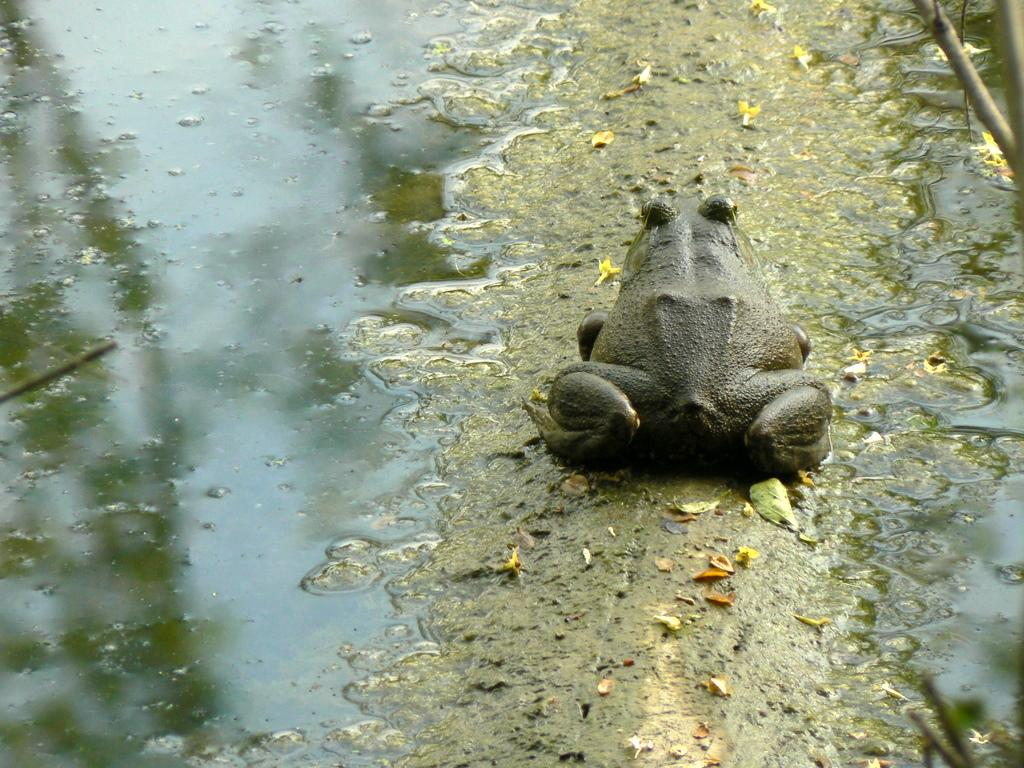What animal is present in the image? There is a frog in the image. Where is the frog located in relation to the mud water? The frog is beside the mud water. What type of cemetery can be seen in the image? There is no cemetery present in the image; it features a frog beside mud water. Can you describe the force exerted by the tiger in the image? There is no tiger present in the image, so it is not possible to describe any force exerted by a tiger. 